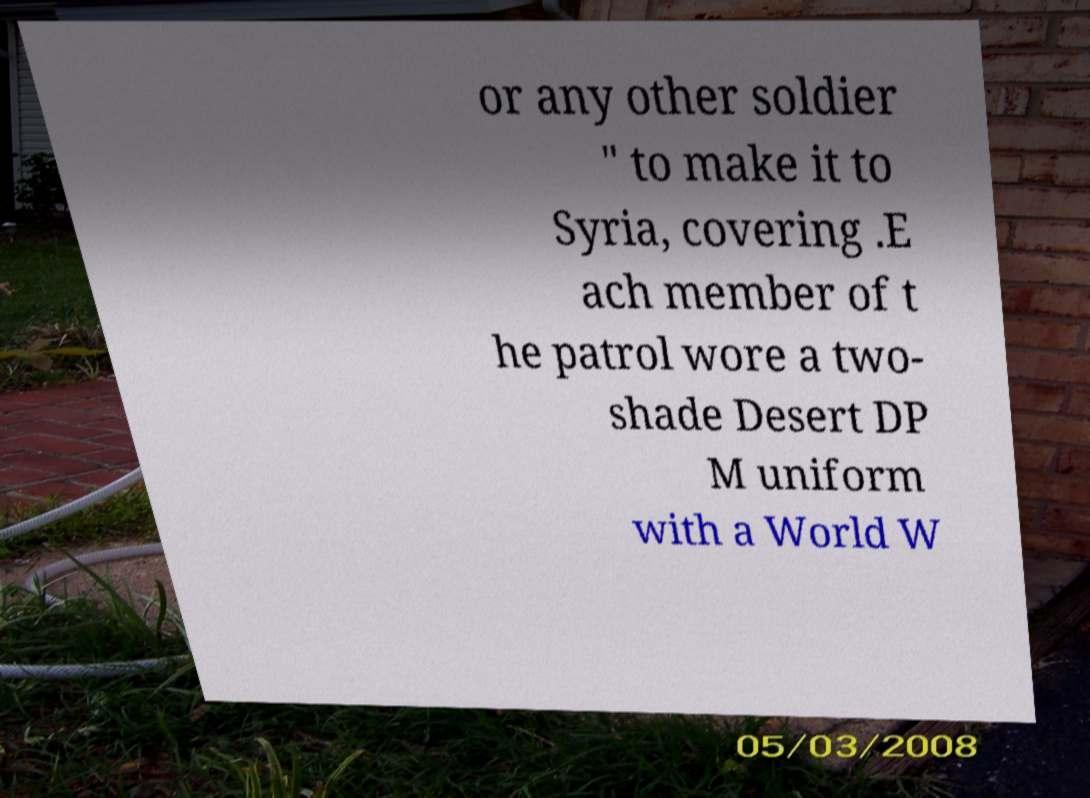I need the written content from this picture converted into text. Can you do that? or any other soldier " to make it to Syria, covering .E ach member of t he patrol wore a two- shade Desert DP M uniform with a World W 